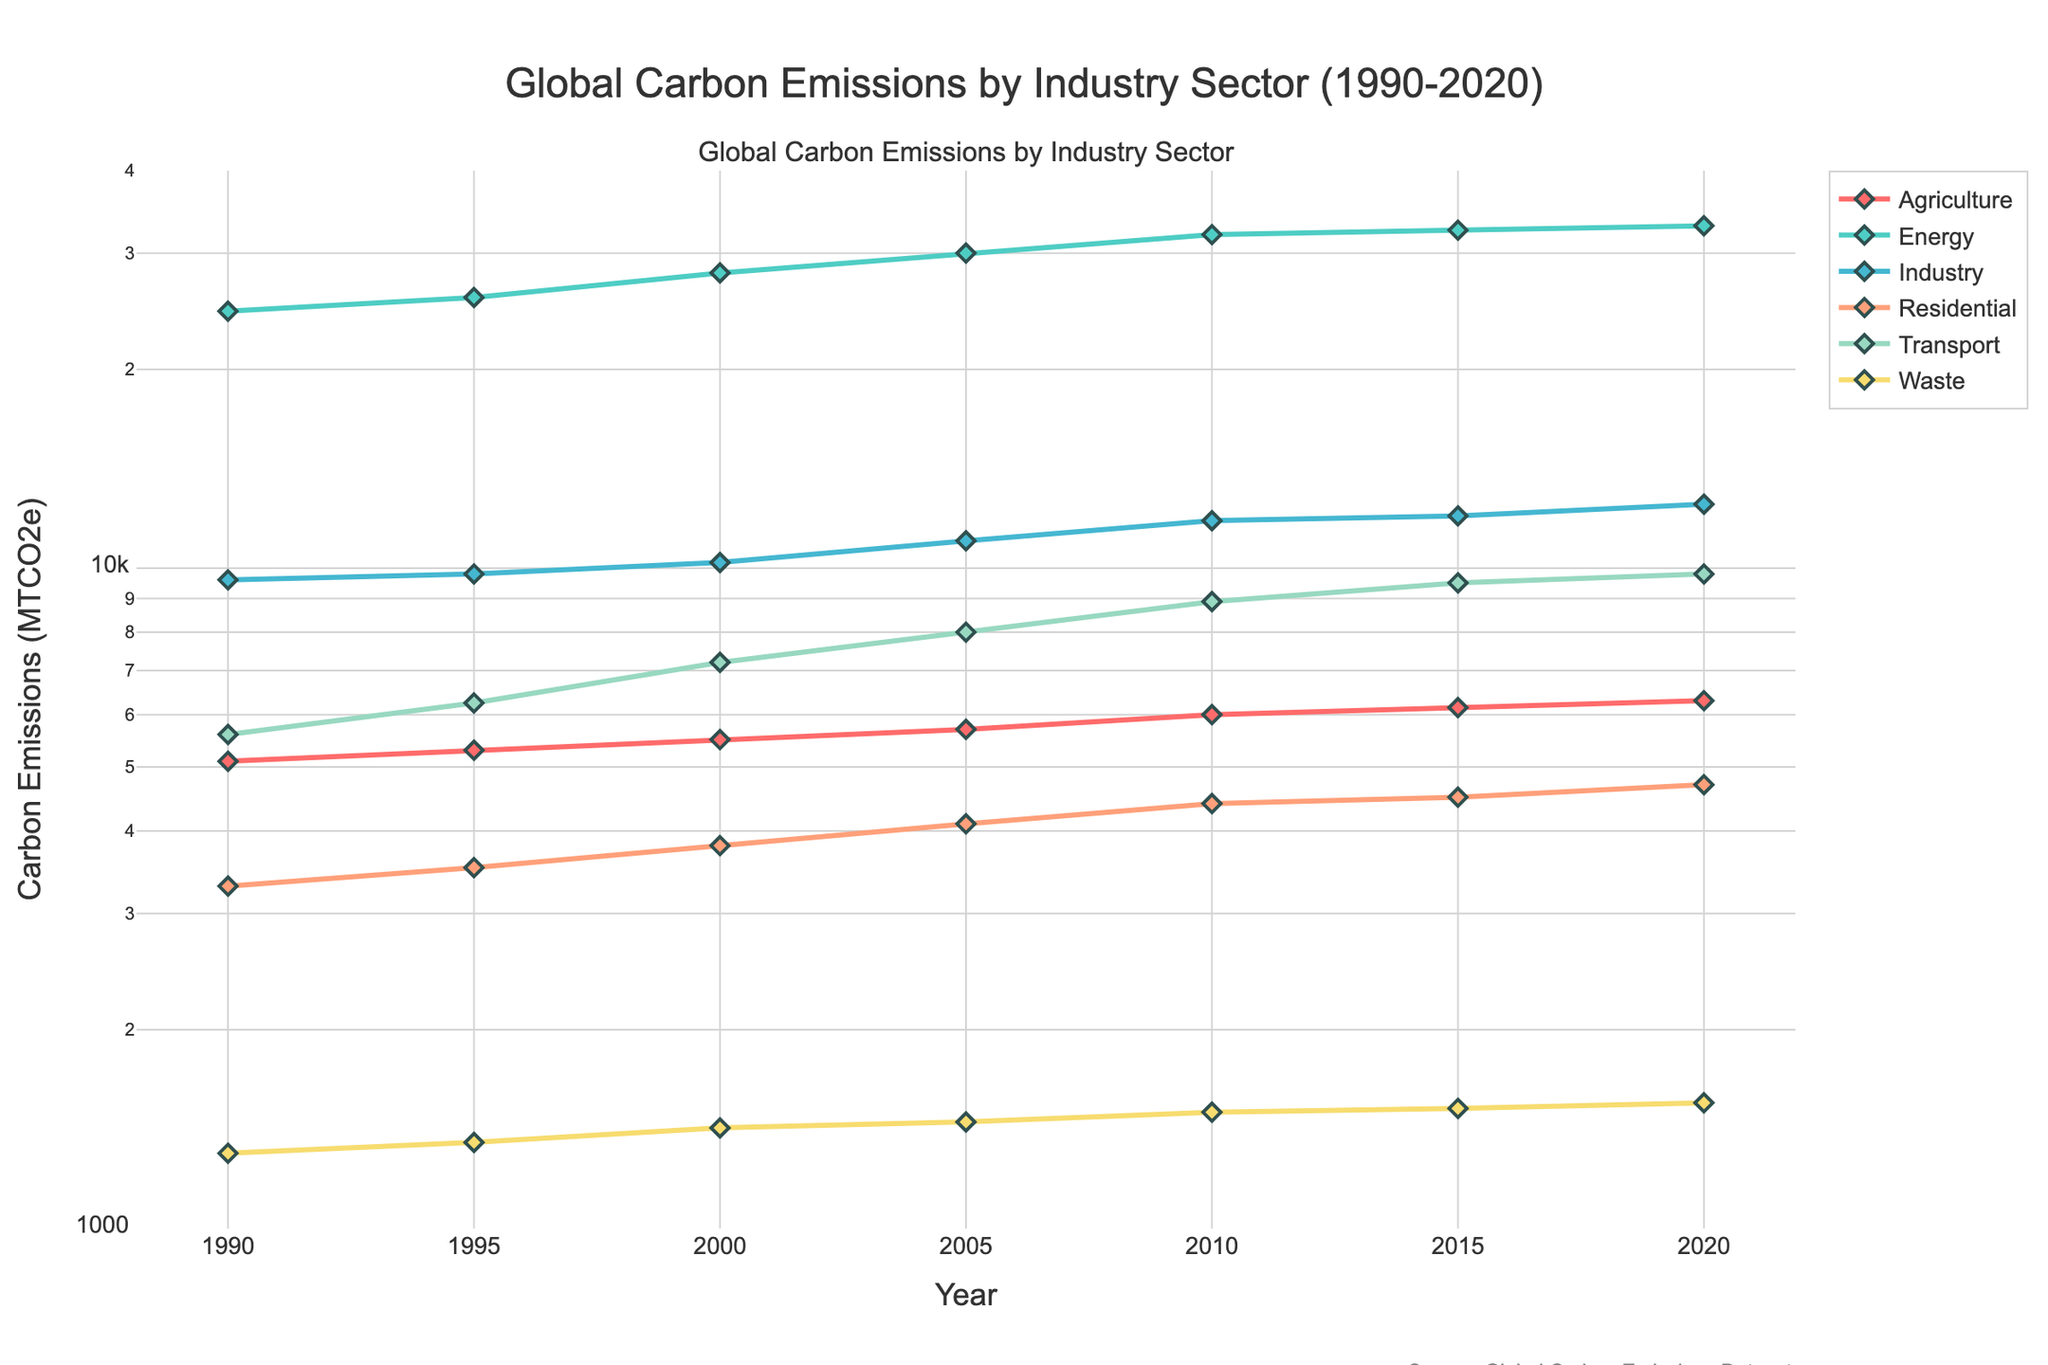What is the title of the plot? The title is usually found at the top of the plot. Here, it reads "Global Carbon Emissions by Industry Sector (1990-2020)" as given in the code details.
Answer: "Global Carbon Emissions by Industry Sector (1990-2020)" How many industry sectors are represented in the plot? By examining the plot legend or distinct lines, one can count the number of different sectors represented. Based on the provided information, there are six sectors: Energy, Industry, Transport, Residential, Agriculture, and Waste.
Answer: Six Which industry sector had the highest carbon emissions in 2020? The highest point on the log scale Y-axis in 2020 indicates the sector with the largest emissions. The Energy sector has the highest value, reaching 33,000 MTCO2e.
Answer: Energy By how much did carbon emissions from the Transport sector increase from 1990 to 2020? Find the value for the Transport sector in both years and subtract the earlier value from the later value. In 1990, Transport emissions were 5,600 MTCO2e, and in 2020, they were 9,800 MTCO2e. The increase is 9800 - 5600 = 4200 MTCO2e.
Answer: 4,200 MTCO2e Which sector experienced the least growth in carbon emissions from 1990 to 2020? Compare the changes in emissions for all sectors from 1990 to 2020. The Residential sector started at 3,300 MTCO2e in 1990 and reached 4,700 MTCO2e in 2020, which is an increase of 1,400 MTCO2e, the smallest compared to other sectors.
Answer: Residential What is the approximate log scale range of carbon emissions shown on the Y-axis? The provided y-axis type is log, and the range is from log10(1000) to log10(40000). This equates to about 3 (since log10(1000) = 3) to about 4.6 (since log10(40000) ≈ 4.6).
Answer: 3 to 4.6 Compare the carbon emissions from the Industry and Agriculture sectors in 2000. Which one was higher and by how much? For 2000, Industry emissions are 10,200 MTCO2e, and Agriculture is 5,500 MTCO2e. Subtract Agriculture's value from Industry's: 10200 - 5500 = 4700 MTCO2e. Industry was higher by 4700 MTCO2e.
Answer: Industry by 4700 MTCO2e What trend do the Waste sector emissions show from 1990 to 2020? Observe the Waste sector's line throughout the plot. It consistently rises from 1990 (1,300 MTCO2e) to 2020 (1,550 MTCO2e). The trend indicates a gradual increase in emissions over these years.
Answer: Gradual increase How does the rate of increase in carbon emissions for the Energy sector compare to the Transport sector from 1990 to 2020? Energy emissions increased from 24,500 MTCO2e to 33,000 MTCO2e, a rise of 8,500 MTCO2e. Transport emissions rose from 5,600 MTCO2e to 9,800 MTCO2e, a rise of 4,200 MTCO2e. The increase in the Energy sector is higher by 8,500 - 4,200 = 4,300 MTCO2e.
Answer: Energy sector increase is higher by 4,300 MTCO2e 